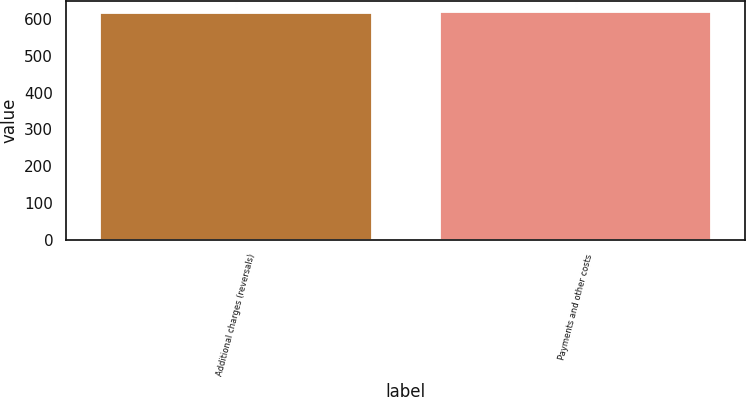Convert chart to OTSL. <chart><loc_0><loc_0><loc_500><loc_500><bar_chart><fcel>Additional charges (reversals)<fcel>Payments and other costs<nl><fcel>618<fcel>618.1<nl></chart> 